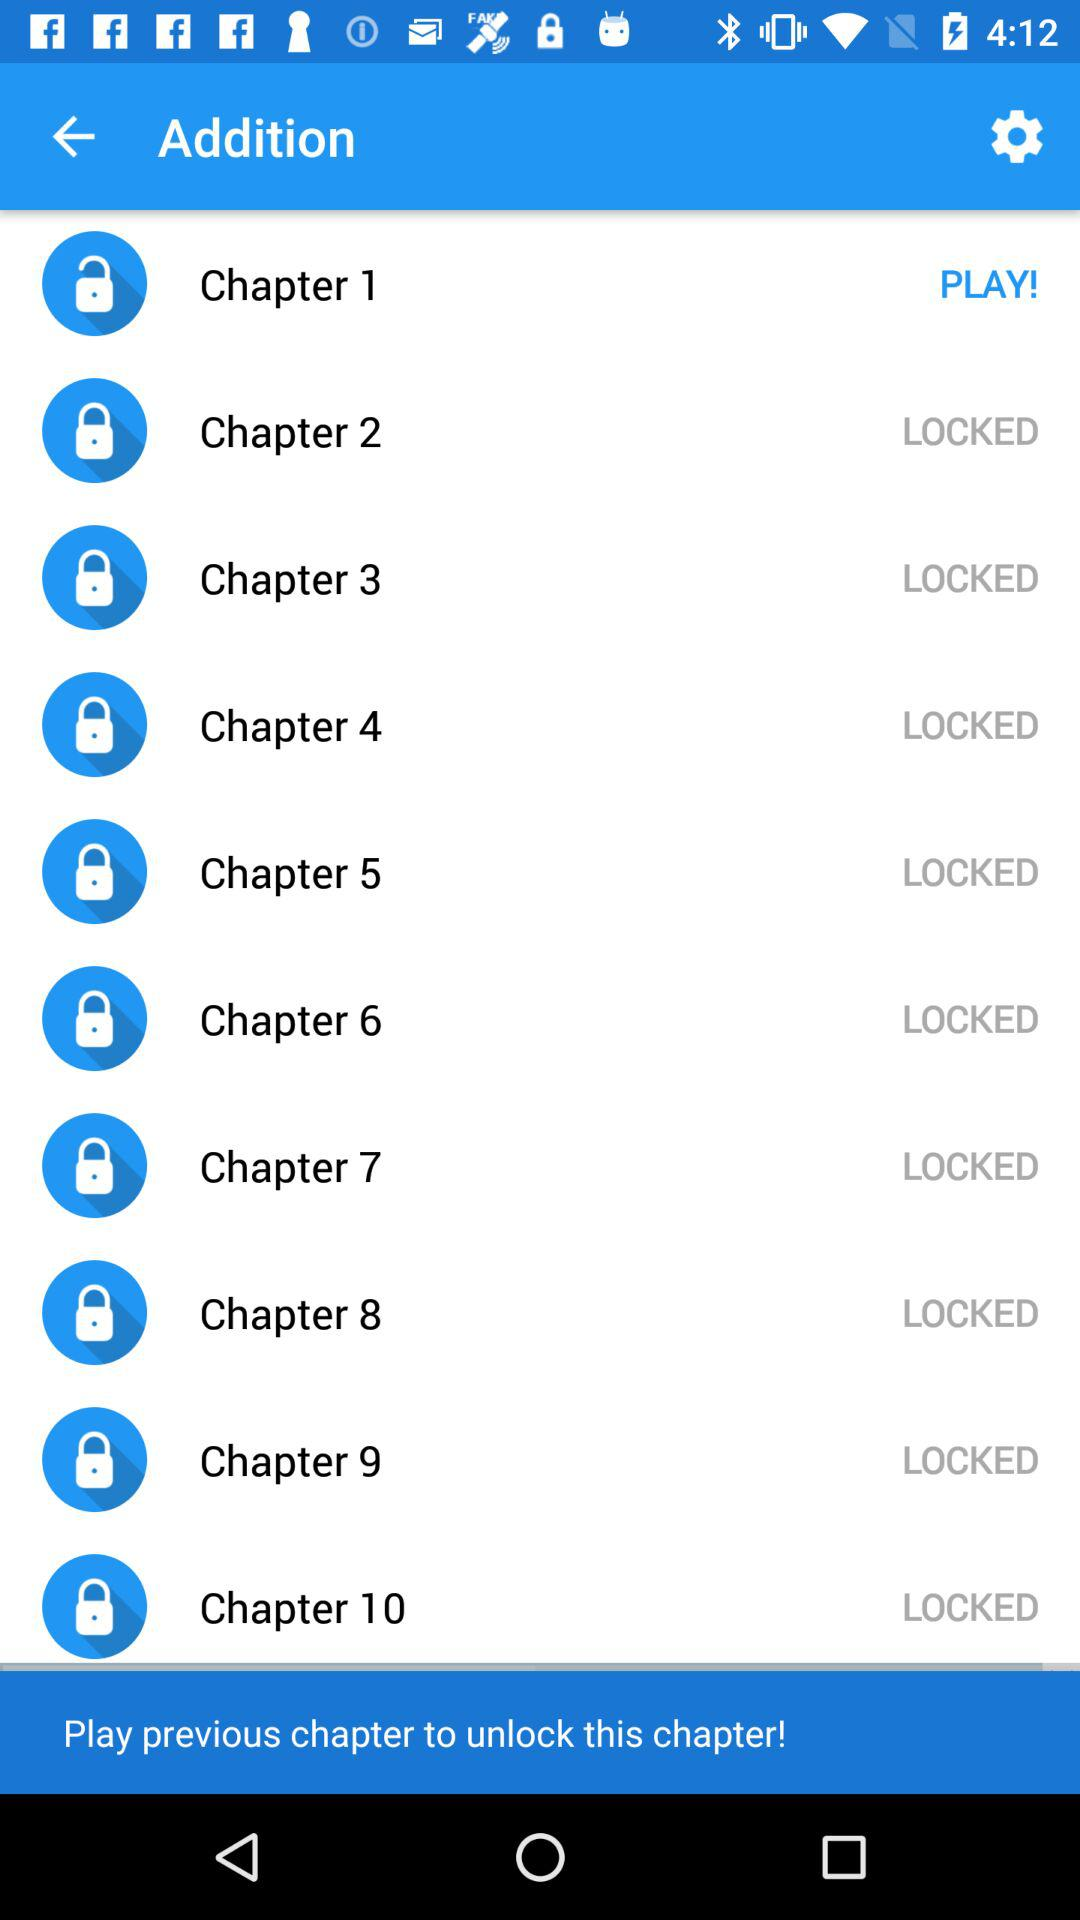How many chapters are in this course?
Answer the question using a single word or phrase. 10 